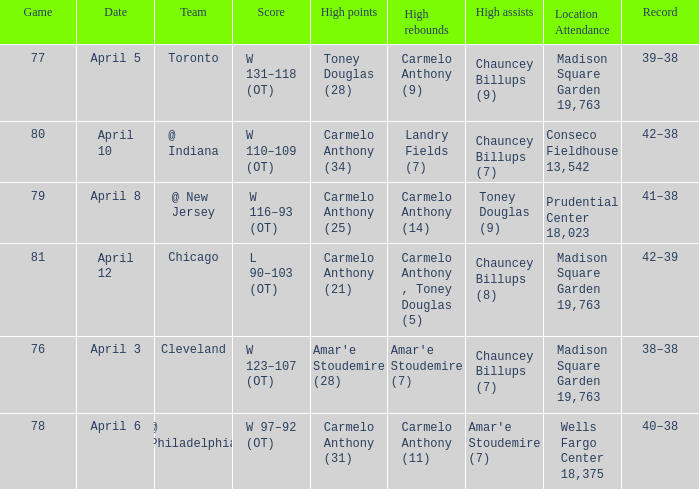Name the date for cleveland April 3. 